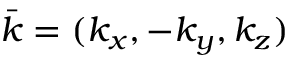<formula> <loc_0><loc_0><loc_500><loc_500>\bar { k } = ( k _ { x } , - k _ { y } , k _ { z } )</formula> 